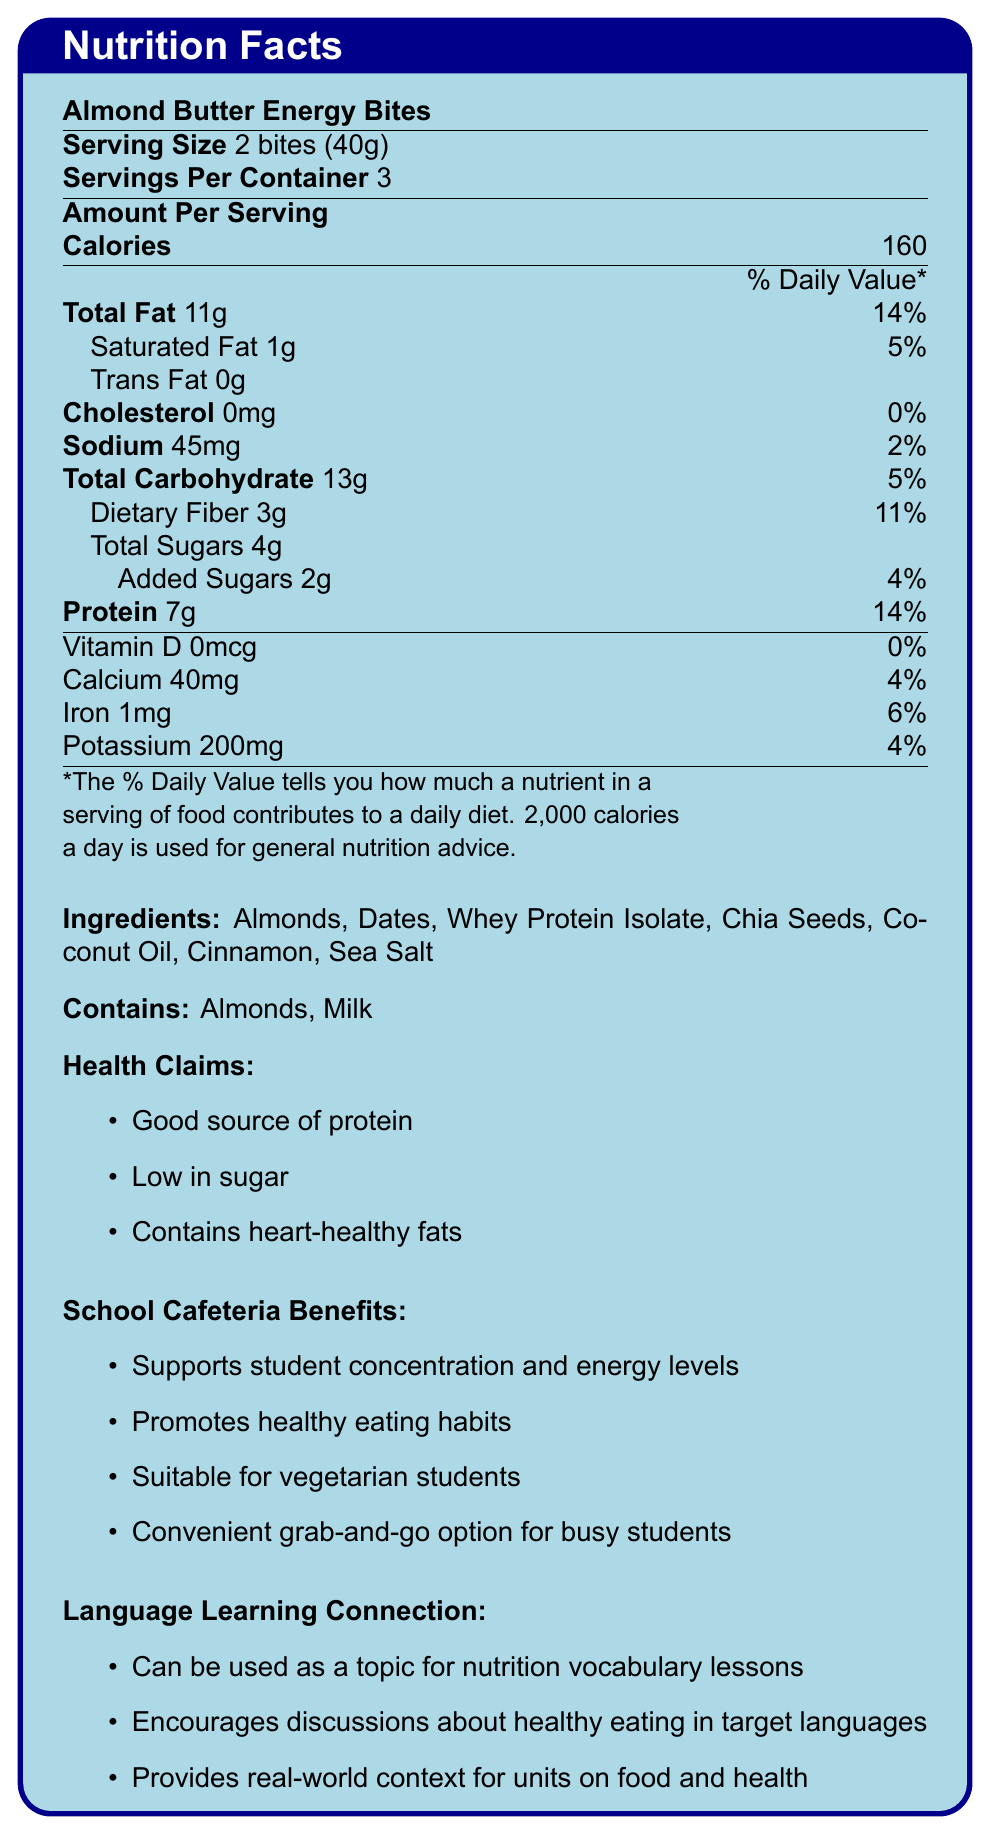what is the serving size for the Almond Butter Energy Bites? The document shows the serving size information directly under the product name, indicating 2 bites (40g).
Answer: 2 bites (40g) how much protein is in one serving? The amount of protein per serving is listed directly in the nutrition facts table as 7g.
Answer: 7g what are the first three ingredients listed for the Almond Butter Energy Bites? The ingredients are listed in the order they appear in the document, with the first three being Almonds, Dates, and Whey Protein Isolate.
Answer: Almonds, Dates, Whey Protein Isolate how many calories are in one serving of Almond Butter Energy Bites? The document lists the calorie count per serving directly in the nutrition facts table as 160 calories.
Answer: 160 calories which nutrient has 0% daily value? The document states that Vitamin D has 0mcg, which is 0% of the daily value.
Answer: Vitamin D how much total fat is in one serving? A. 5g B. 11g C. 7g D. 14g The document lists the total fat amount per serving as 11g.
Answer: B. 11g what percentage of the daily value of fiber is in one serving? A. 4% B. 5% C. 11% D. 14% The document indicates that the dietary fiber content per serving contributes to 11% of the daily value.
Answer: C. 11% are the Almond Butter Energy Bites suitable for vegetarian students? The document mentions that the product is suitable for vegetarian students in the school cafeteria benefits section.
Answer: Yes does the product contain any trans fat? The nutrition facts table lists trans fat as 0g, indicating there is no trans fat in the product.
Answer: No how many servings are there in one container? The document indicates that each container of Almond Butter Energy Bites contains 3 servings.
Answer: 3 servings what is the main idea of the nutrition facts label? The document extensively covers the nutritional aspects, ingredients, and benefits of the Almond Butter Energy Bites, highlighting its suitability for a school cafeteria and potential educational uses.
Answer: The document provides nutritional information for Almond Butter Energy Bites, a healthy snack option low in sugar and high in protein, detailing serving size, calories, nutrients, ingredients, allergens, health benefits, school cafeteria benefits, and language learning connections. what is the percentage of daily value for calcium in one serving? According to the document, the calcium content per serving is 40mg, which is 4% of the daily value.
Answer: 4% does the product contain any peanuts? The document does not mention peanuts in the ingredients or allergens section, but it doesn't explicitly state whether there is a risk of cross-contamination or if peanuts are entirely absent from the production environment.
Answer: Not enough information why is the product considered low in sugar? The total sugar content per serving is relatively low at 4g, with only 2g coming from added sugars, which supports the claim of being low in sugar.
Answer: It contains only 4g of total sugars per serving, of which 2g are added sugars, making it a low-sugar option. what benefits do the Almond Butter Energy Bites provide to the school cafeteria? The document lists several benefits of the product for the school cafeteria, emphasizing its support for student health and convenience.
Answer: Supports student concentration and energy levels, promotes healthy eating habits, suitable for vegetarian students, and is a convenient grab-and-go option for busy students. how can the Almond Butter Energy Bites be used in language learning? The document outlines connections to language learning by using the product as a resource in various educational contexts, fostering discussions and vocabulary learning related to nutrition and healthy lifestyles.
Answer: They can be used as a topic for nutrition vocabulary lessons, to encourage discussions about healthy eating, and to provide real-world context for units on food and health. 